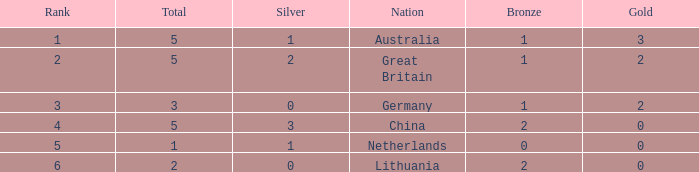What is the average Rank when there are 2 bronze, the total is 2 and gold is less than 0? None. 